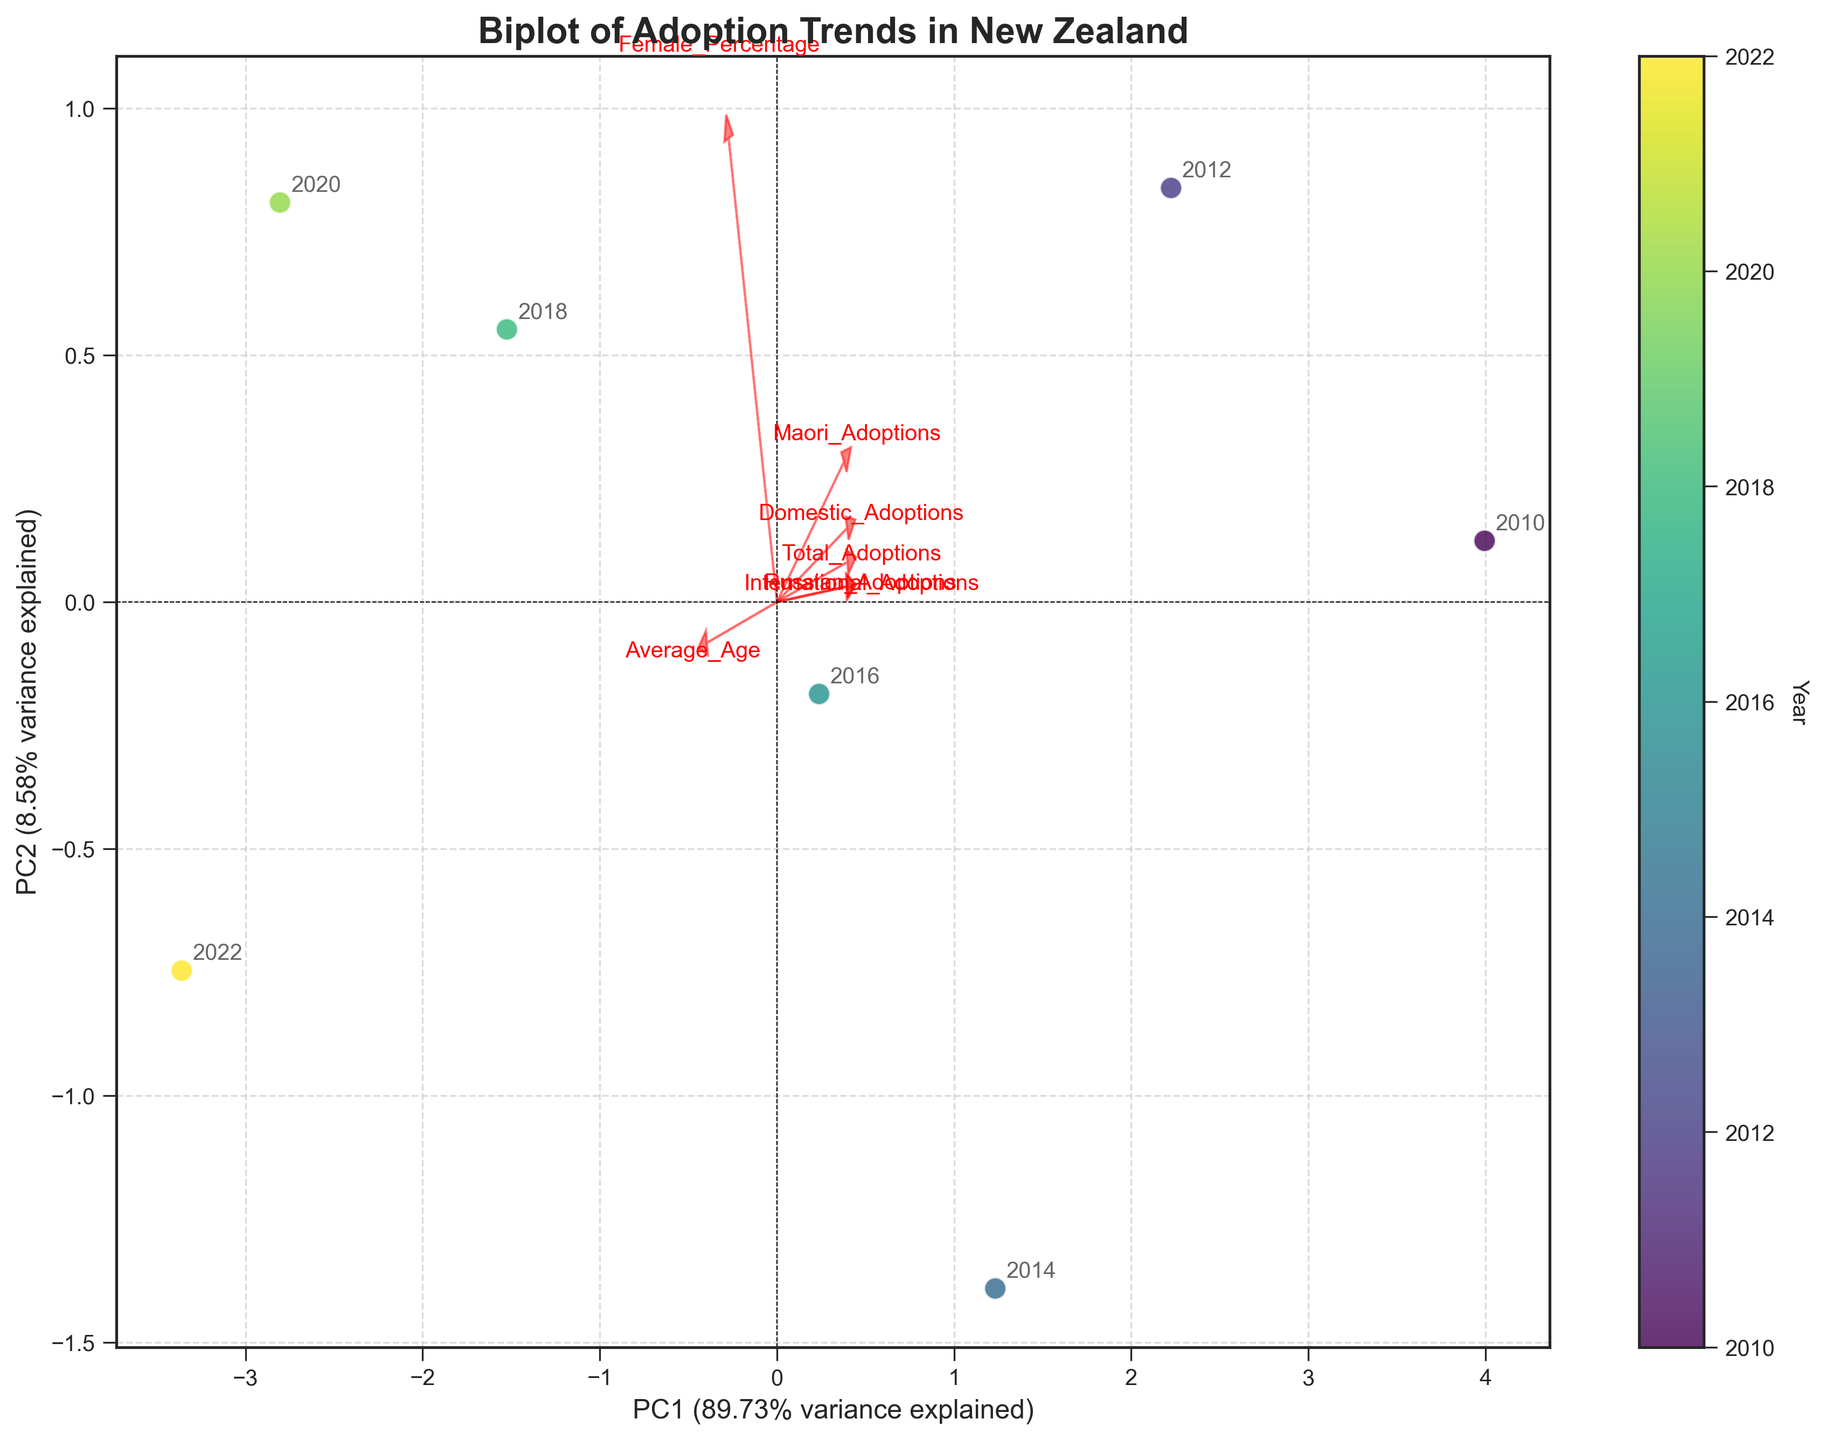What is the title of the plot? The title of the plot is typically located at the top center and summarizes the content or purpose of the visualization. In this case, the title is "Biplot of Adoption Trends in New Zealand" as indicated in the code.
Answer: Biplot of Adoption Trends in New Zealand What are the labeled principal components on the axes, and what percentage of variance do they explain? The axes in a PCA biplot represent the principal components (PC1 and PC2). The x-axis is labeled 'PC1' and the y-axis is 'PC2'. The labels also include the percentage of variance each component explains. According to the code, they are formatted as 'PC1 (explained_variance_1%)' and 'PC2 (explained_variance_2%)'. Substitute 'explained_variance_1' and 'explained_variance_2' with their respective explained variance ratios found in the plot.
Answer: PC1 and PC2, with their respective percentage variances How are the years represented on the plot? The years are represented by color-coded points in the color gradient (viridis), with annotations next to each point. This allows us to identify specific years based on their position and color in the plot.
Answer: Color-coded points and annotations Which feature has the highest loading on PC1? To determine the feature with the highest loading on PC1, examine the arrows extending from the origin in the plot. The length of the arrow along the PC1 axis indicates the loading magnitude. The feature with the arrow that extends most positively or negatively along PC1 has the highest loading. Look for the feature text that corresponds with this arrow.
Answer: Feature with the highest loading on PC1 How has the trend in 'Russian Adoptions' changed over the years? To identify the trend in 'Russian Adoptions' over the years, look at the feature loading arrow for 'Russian Adoptions' and its annotations’ positions in relation to the years. The positions of the points from earlier to later years indicate the trend of this attribute over time.
Answer: Decreasing trend Comparing 2010 and 2022, which year had a higher percentage of female adoptions? To answer this, check the plot for the positions of the years 2010 and 2022 on the axis representing 'Female_Percentage'. The position of these years relative to the loading arrow for 'Female_Percentage' indicates which year had a higher value.
Answer: 2020 or 2022 Which feature appears to be least correlated with the others? Features that appear least correlated with others will have arrows pointed in directions substantially different from the majority. These arrows will not cluster with others or point towards opposite directions, indicating weaker or no correlation. Identify the feature with an arrow that fits this description.
Answer: Least correlated feature Which principal component explains more variance in the data? Examine the axis labels to see which principal component (PC1 or PC2) has a higher percentage of variance explained. The component with a higher percentage value in its label explains more variance.
Answer: PC1 or PC2 (whichever has a higher percentage) Of the features plotted, which factors contribute most strongly to the variance explained by PC2? Look for the arrows representing each feature and determine which arrows extend most along the y-axis (PC2 direction). The corresponding features are those contributing most strongly to PC2.
Answer: Features contributing to PC2 